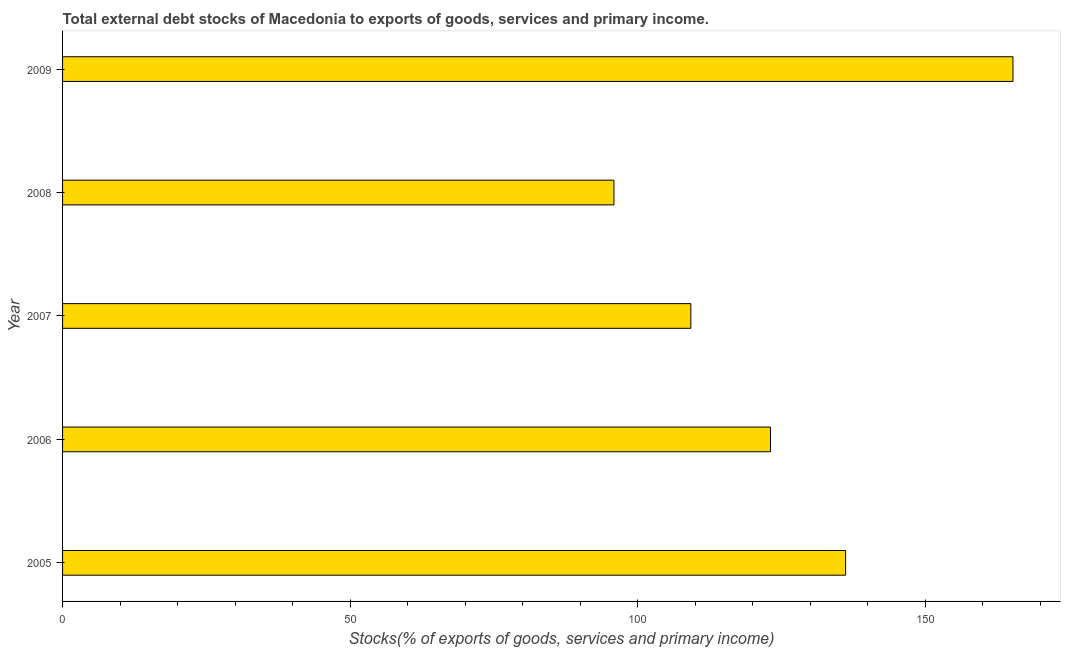What is the title of the graph?
Make the answer very short. Total external debt stocks of Macedonia to exports of goods, services and primary income. What is the label or title of the X-axis?
Provide a succinct answer. Stocks(% of exports of goods, services and primary income). What is the external debt stocks in 2006?
Your answer should be very brief. 123.09. Across all years, what is the maximum external debt stocks?
Provide a succinct answer. 165.25. Across all years, what is the minimum external debt stocks?
Your response must be concise. 95.87. In which year was the external debt stocks maximum?
Keep it short and to the point. 2009. What is the sum of the external debt stocks?
Offer a terse response. 629.61. What is the difference between the external debt stocks in 2005 and 2008?
Provide a succinct answer. 40.28. What is the average external debt stocks per year?
Your answer should be compact. 125.92. What is the median external debt stocks?
Provide a short and direct response. 123.09. Do a majority of the years between 2008 and 2009 (inclusive) have external debt stocks greater than 90 %?
Offer a terse response. Yes. What is the ratio of the external debt stocks in 2005 to that in 2009?
Offer a very short reply. 0.82. What is the difference between the highest and the second highest external debt stocks?
Offer a terse response. 29.1. Is the sum of the external debt stocks in 2005 and 2007 greater than the maximum external debt stocks across all years?
Give a very brief answer. Yes. What is the difference between the highest and the lowest external debt stocks?
Provide a short and direct response. 69.38. How many bars are there?
Your answer should be compact. 5. What is the Stocks(% of exports of goods, services and primary income) of 2005?
Your answer should be very brief. 136.15. What is the Stocks(% of exports of goods, services and primary income) in 2006?
Your response must be concise. 123.09. What is the Stocks(% of exports of goods, services and primary income) in 2007?
Offer a very short reply. 109.24. What is the Stocks(% of exports of goods, services and primary income) in 2008?
Offer a very short reply. 95.87. What is the Stocks(% of exports of goods, services and primary income) of 2009?
Provide a succinct answer. 165.25. What is the difference between the Stocks(% of exports of goods, services and primary income) in 2005 and 2006?
Provide a short and direct response. 13.06. What is the difference between the Stocks(% of exports of goods, services and primary income) in 2005 and 2007?
Ensure brevity in your answer.  26.91. What is the difference between the Stocks(% of exports of goods, services and primary income) in 2005 and 2008?
Give a very brief answer. 40.28. What is the difference between the Stocks(% of exports of goods, services and primary income) in 2005 and 2009?
Provide a succinct answer. -29.1. What is the difference between the Stocks(% of exports of goods, services and primary income) in 2006 and 2007?
Ensure brevity in your answer.  13.85. What is the difference between the Stocks(% of exports of goods, services and primary income) in 2006 and 2008?
Ensure brevity in your answer.  27.22. What is the difference between the Stocks(% of exports of goods, services and primary income) in 2006 and 2009?
Ensure brevity in your answer.  -42.16. What is the difference between the Stocks(% of exports of goods, services and primary income) in 2007 and 2008?
Make the answer very short. 13.37. What is the difference between the Stocks(% of exports of goods, services and primary income) in 2007 and 2009?
Your answer should be very brief. -56.01. What is the difference between the Stocks(% of exports of goods, services and primary income) in 2008 and 2009?
Your answer should be compact. -69.38. What is the ratio of the Stocks(% of exports of goods, services and primary income) in 2005 to that in 2006?
Ensure brevity in your answer.  1.11. What is the ratio of the Stocks(% of exports of goods, services and primary income) in 2005 to that in 2007?
Provide a succinct answer. 1.25. What is the ratio of the Stocks(% of exports of goods, services and primary income) in 2005 to that in 2008?
Provide a succinct answer. 1.42. What is the ratio of the Stocks(% of exports of goods, services and primary income) in 2005 to that in 2009?
Ensure brevity in your answer.  0.82. What is the ratio of the Stocks(% of exports of goods, services and primary income) in 2006 to that in 2007?
Make the answer very short. 1.13. What is the ratio of the Stocks(% of exports of goods, services and primary income) in 2006 to that in 2008?
Offer a terse response. 1.28. What is the ratio of the Stocks(% of exports of goods, services and primary income) in 2006 to that in 2009?
Make the answer very short. 0.74. What is the ratio of the Stocks(% of exports of goods, services and primary income) in 2007 to that in 2008?
Offer a terse response. 1.14. What is the ratio of the Stocks(% of exports of goods, services and primary income) in 2007 to that in 2009?
Provide a succinct answer. 0.66. What is the ratio of the Stocks(% of exports of goods, services and primary income) in 2008 to that in 2009?
Keep it short and to the point. 0.58. 